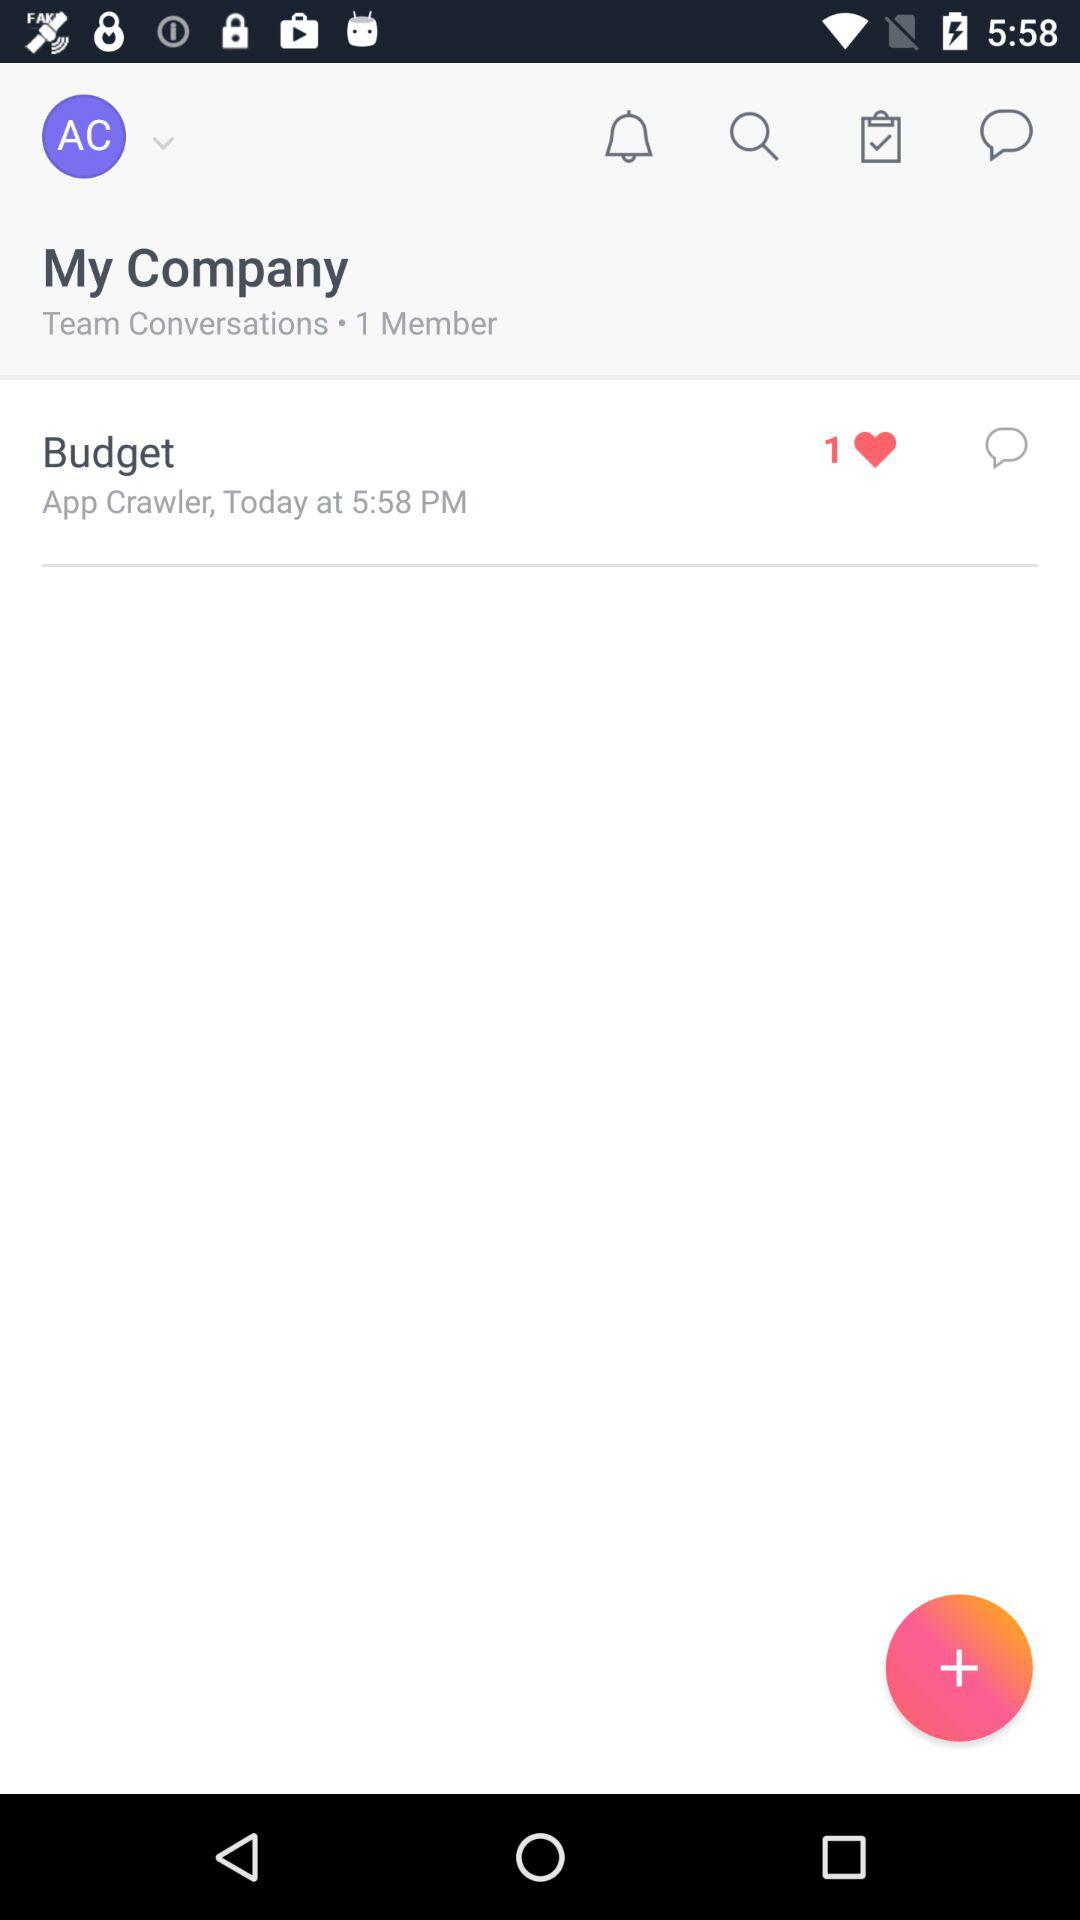How many people like "Budget"? The number of people who like "Budget" is 1. 